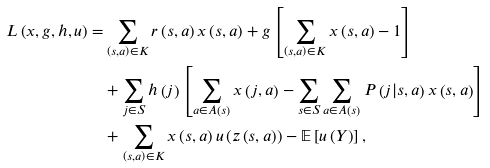Convert formula to latex. <formula><loc_0><loc_0><loc_500><loc_500>L \left ( x , g , h , u \right ) = & \sum _ { \left ( s , a \right ) \in K } r \left ( s , a \right ) x \left ( s , a \right ) + g \left [ \sum _ { \left ( s , a \right ) \in K } x \left ( s , a \right ) - 1 \right ] \\ & + \sum _ { j \in S } h \left ( j \right ) \left [ \sum _ { a \in A \left ( s \right ) } x \left ( j , a \right ) - \sum _ { s \in S } \sum _ { a \in A \left ( s \right ) } P \left ( j | s , a \right ) x \left ( s , a \right ) \right ] \\ & + \sum _ { \left ( s , a \right ) \in K } x \left ( s , a \right ) u \left ( z \left ( s , a \right ) \right ) - \mathbb { E } \left [ u \left ( Y \right ) \right ] ,</formula> 